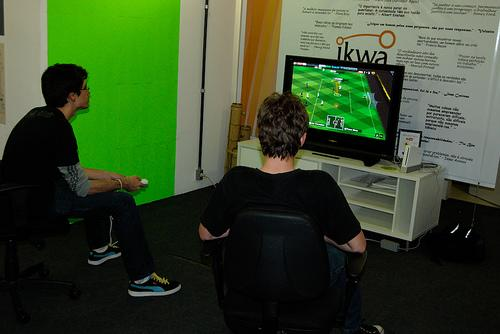What is the white thing the man is holding? controller 